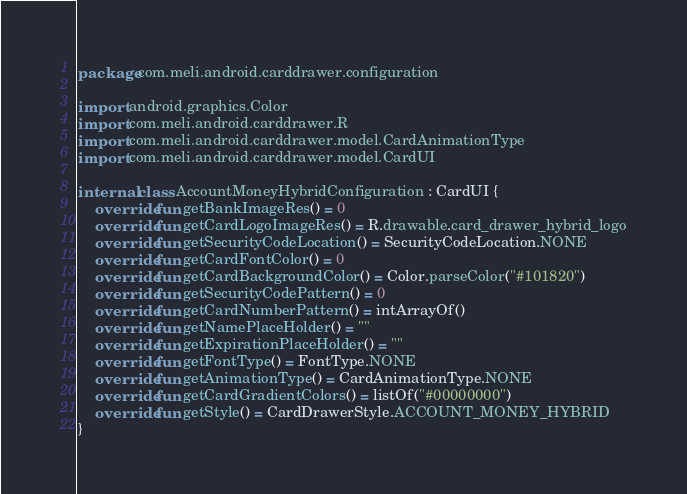Convert code to text. <code><loc_0><loc_0><loc_500><loc_500><_Kotlin_>package com.meli.android.carddrawer.configuration

import android.graphics.Color
import com.meli.android.carddrawer.R
import com.meli.android.carddrawer.model.CardAnimationType
import com.meli.android.carddrawer.model.CardUI

internal class AccountMoneyHybridConfiguration : CardUI {
    override fun getBankImageRes() = 0
    override fun getCardLogoImageRes() = R.drawable.card_drawer_hybrid_logo
    override fun getSecurityCodeLocation() = SecurityCodeLocation.NONE
    override fun getCardFontColor() = 0
    override fun getCardBackgroundColor() = Color.parseColor("#101820")
    override fun getSecurityCodePattern() = 0
    override fun getCardNumberPattern() = intArrayOf()
    override fun getNamePlaceHolder() = ""
    override fun getExpirationPlaceHolder() = ""
    override fun getFontType() = FontType.NONE
    override fun getAnimationType() = CardAnimationType.NONE
    override fun getCardGradientColors() = listOf("#00000000")
    override fun getStyle() = CardDrawerStyle.ACCOUNT_MONEY_HYBRID
}
</code> 